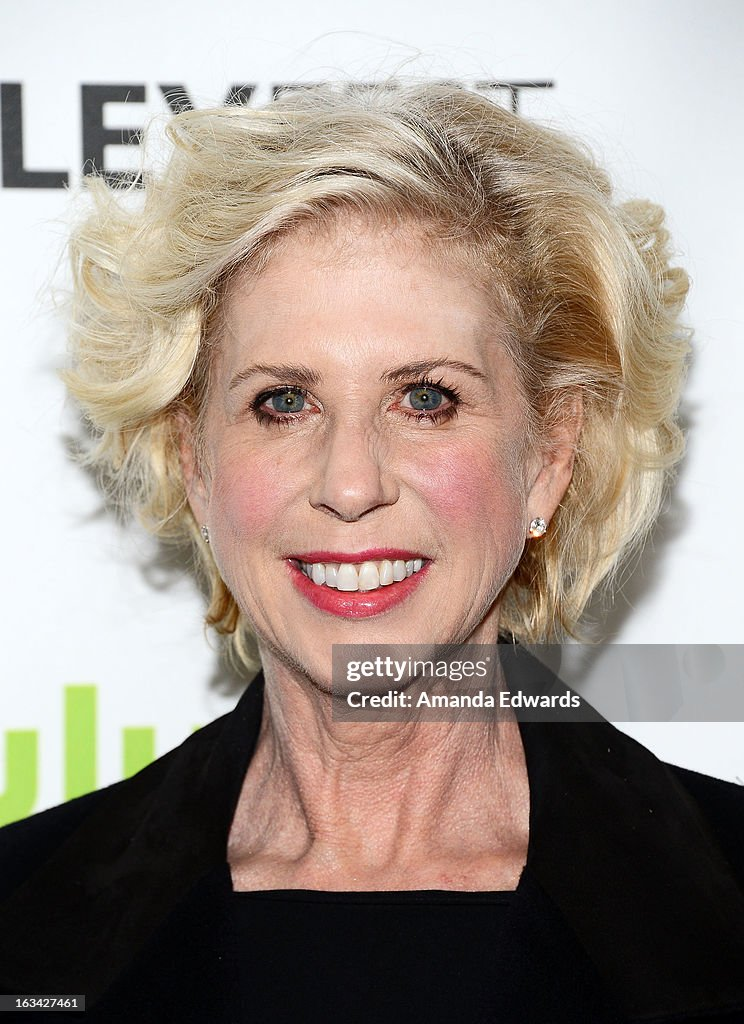What is the probable event or setting suggested by the partial background visible in the image? The partial background visible in the image includes a step-and-repeat banner, typically seen at promotional events in the entertainment industry. Such events often include premieres, award shows, and press events where attendees are photographed against branded backdrops. The banner's presence indicates a formal setting where the individuals are likely of significance, potentially celebrities or public figures, attending for publicity purposes. 